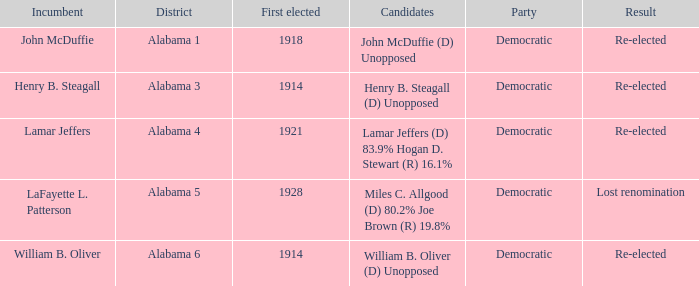How many in total were elected first in lost renomination? 1.0. 